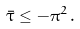Convert formula to latex. <formula><loc_0><loc_0><loc_500><loc_500>\bar { \tau } \leq - \pi ^ { 2 } \, .</formula> 